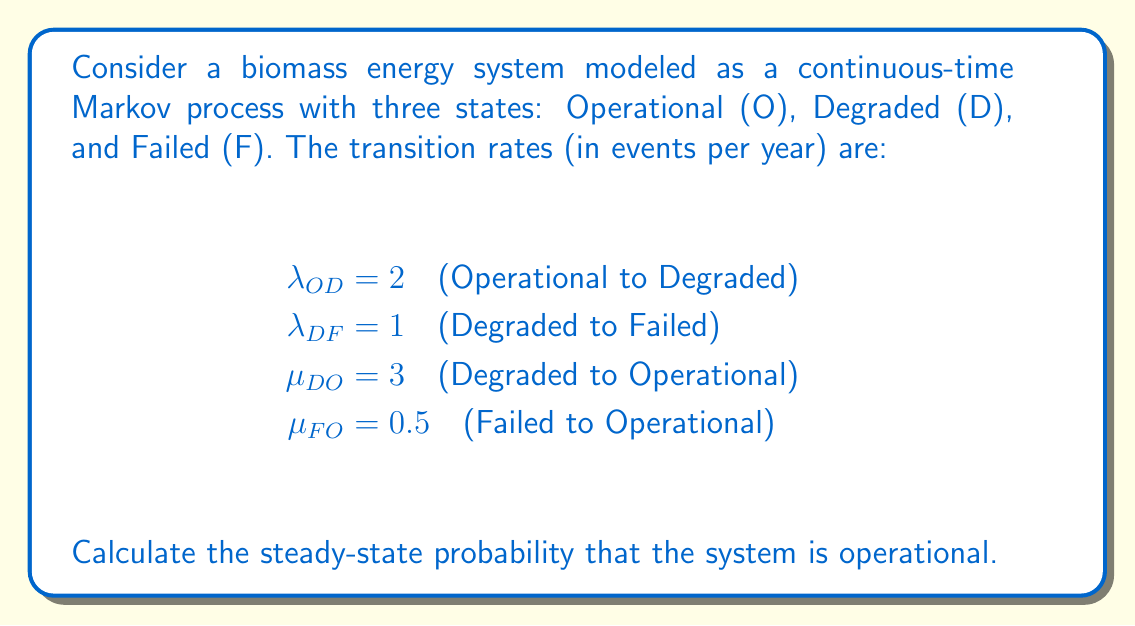Give your solution to this math problem. To solve this problem, we'll follow these steps:

1) First, let's define the state probabilities:
   $P_O$ = Probability of being in Operational state
   $P_D$ = Probability of being in Degraded state
   $P_F$ = Probability of being in Failed state

2) In steady-state, the rate of flow into each state equals the rate of flow out. This gives us the following equations:

   For state O: $\mu_{DO}P_D + \mu_{FO}P_F = \lambda_{OD}P_O$
   For state D: $\lambda_{OD}P_O = (\mu_{DO} + \lambda_{DF})P_D$
   For state F: $\lambda_{DF}P_D = \mu_{FO}P_F$

3) We also know that the probabilities must sum to 1:

   $P_O + P_D + P_F = 1$

4) From the equation for state F, we can express $P_F$ in terms of $P_D$:

   $P_F = \frac{\lambda_{DF}}{\mu_{FO}}P_D = 2P_D$

5) Substituting this into the equation for state O:

   $\mu_{DO}P_D + \mu_{FO}(2P_D) = \lambda_{OD}P_O$
   $3P_D + 0.5(2P_D) = 2P_O$
   $4P_D = 2P_O$
   $P_D = \frac{1}{2}P_O$

6) Now we can express all probabilities in terms of $P_O$:

   $P_D = \frac{1}{2}P_O$
   $P_F = 2P_D = P_O$

7) Substituting into the sum of probabilities equation:

   $P_O + \frac{1}{2}P_O + P_O = 1$
   $\frac{5}{2}P_O = 1$

8) Solving for $P_O$:

   $P_O = \frac{2}{5} = 0.4$

Therefore, the steady-state probability that the system is operational is 0.4 or 40%.
Answer: 0.4 